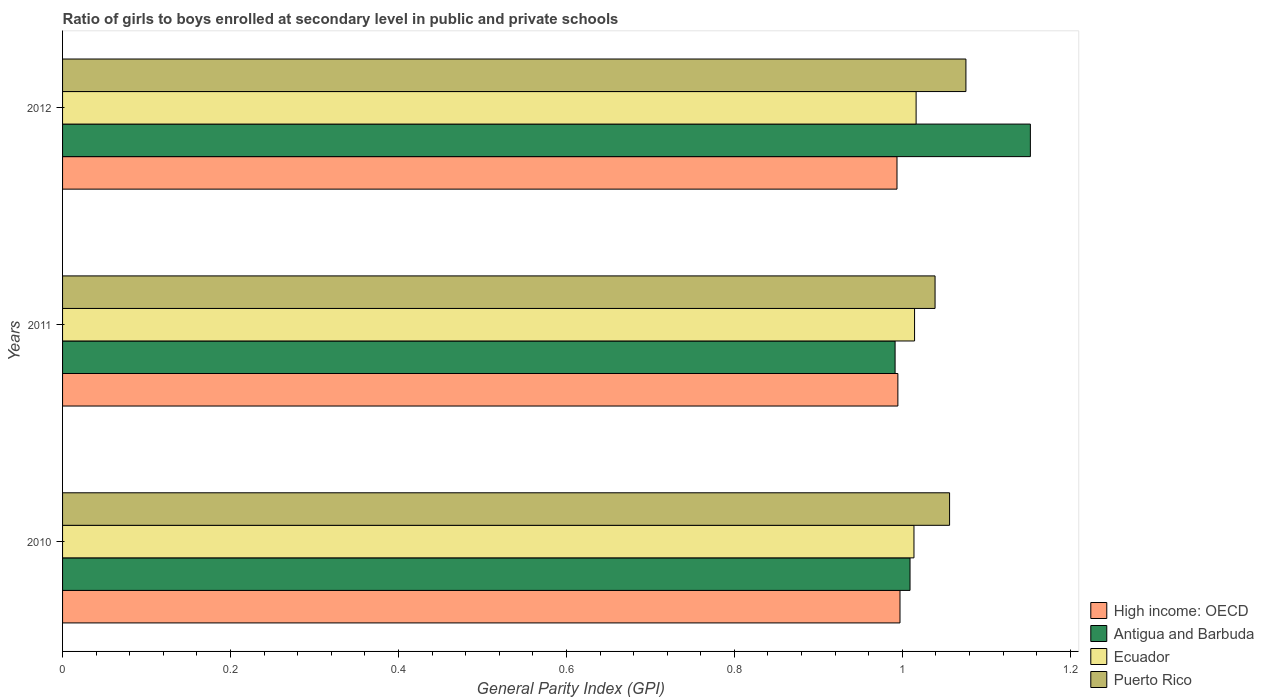How many bars are there on the 2nd tick from the top?
Offer a terse response. 4. What is the label of the 3rd group of bars from the top?
Your answer should be very brief. 2010. What is the general parity index in Antigua and Barbuda in 2012?
Provide a short and direct response. 1.15. Across all years, what is the maximum general parity index in Ecuador?
Keep it short and to the point. 1.02. Across all years, what is the minimum general parity index in Puerto Rico?
Keep it short and to the point. 1.04. In which year was the general parity index in Ecuador minimum?
Provide a short and direct response. 2010. What is the total general parity index in High income: OECD in the graph?
Offer a very short reply. 2.99. What is the difference between the general parity index in Ecuador in 2010 and that in 2011?
Your response must be concise. -0. What is the difference between the general parity index in Puerto Rico in 2011 and the general parity index in Ecuador in 2012?
Your response must be concise. 0.02. What is the average general parity index in Ecuador per year?
Keep it short and to the point. 1.01. In the year 2011, what is the difference between the general parity index in Puerto Rico and general parity index in Antigua and Barbuda?
Keep it short and to the point. 0.05. In how many years, is the general parity index in High income: OECD greater than 0.24000000000000002 ?
Give a very brief answer. 3. What is the ratio of the general parity index in Puerto Rico in 2010 to that in 2011?
Give a very brief answer. 1.02. Is the difference between the general parity index in Puerto Rico in 2011 and 2012 greater than the difference between the general parity index in Antigua and Barbuda in 2011 and 2012?
Give a very brief answer. Yes. What is the difference between the highest and the second highest general parity index in High income: OECD?
Provide a succinct answer. 0. What is the difference between the highest and the lowest general parity index in Puerto Rico?
Your answer should be very brief. 0.04. What does the 3rd bar from the top in 2012 represents?
Provide a short and direct response. Antigua and Barbuda. What does the 2nd bar from the bottom in 2012 represents?
Your answer should be compact. Antigua and Barbuda. How many bars are there?
Provide a short and direct response. 12. Are all the bars in the graph horizontal?
Make the answer very short. Yes. How many years are there in the graph?
Provide a short and direct response. 3. What is the difference between two consecutive major ticks on the X-axis?
Provide a short and direct response. 0.2. Are the values on the major ticks of X-axis written in scientific E-notation?
Ensure brevity in your answer.  No. Does the graph contain any zero values?
Make the answer very short. No. Does the graph contain grids?
Keep it short and to the point. No. How many legend labels are there?
Offer a very short reply. 4. What is the title of the graph?
Provide a short and direct response. Ratio of girls to boys enrolled at secondary level in public and private schools. Does "Syrian Arab Republic" appear as one of the legend labels in the graph?
Your answer should be very brief. No. What is the label or title of the X-axis?
Provide a succinct answer. General Parity Index (GPI). What is the label or title of the Y-axis?
Your response must be concise. Years. What is the General Parity Index (GPI) of High income: OECD in 2010?
Ensure brevity in your answer.  1. What is the General Parity Index (GPI) of Antigua and Barbuda in 2010?
Make the answer very short. 1.01. What is the General Parity Index (GPI) in Ecuador in 2010?
Your response must be concise. 1.01. What is the General Parity Index (GPI) of Puerto Rico in 2010?
Your response must be concise. 1.06. What is the General Parity Index (GPI) in High income: OECD in 2011?
Your answer should be compact. 0.99. What is the General Parity Index (GPI) in Antigua and Barbuda in 2011?
Keep it short and to the point. 0.99. What is the General Parity Index (GPI) of Ecuador in 2011?
Provide a succinct answer. 1.01. What is the General Parity Index (GPI) of Puerto Rico in 2011?
Give a very brief answer. 1.04. What is the General Parity Index (GPI) of High income: OECD in 2012?
Your response must be concise. 0.99. What is the General Parity Index (GPI) of Antigua and Barbuda in 2012?
Provide a succinct answer. 1.15. What is the General Parity Index (GPI) in Ecuador in 2012?
Offer a very short reply. 1.02. What is the General Parity Index (GPI) of Puerto Rico in 2012?
Your response must be concise. 1.08. Across all years, what is the maximum General Parity Index (GPI) in High income: OECD?
Make the answer very short. 1. Across all years, what is the maximum General Parity Index (GPI) of Antigua and Barbuda?
Provide a short and direct response. 1.15. Across all years, what is the maximum General Parity Index (GPI) in Ecuador?
Keep it short and to the point. 1.02. Across all years, what is the maximum General Parity Index (GPI) of Puerto Rico?
Your answer should be very brief. 1.08. Across all years, what is the minimum General Parity Index (GPI) of High income: OECD?
Give a very brief answer. 0.99. Across all years, what is the minimum General Parity Index (GPI) of Antigua and Barbuda?
Offer a very short reply. 0.99. Across all years, what is the minimum General Parity Index (GPI) of Ecuador?
Provide a succinct answer. 1.01. Across all years, what is the minimum General Parity Index (GPI) of Puerto Rico?
Make the answer very short. 1.04. What is the total General Parity Index (GPI) in High income: OECD in the graph?
Offer a terse response. 2.99. What is the total General Parity Index (GPI) of Antigua and Barbuda in the graph?
Keep it short and to the point. 3.15. What is the total General Parity Index (GPI) of Ecuador in the graph?
Your answer should be compact. 3.04. What is the total General Parity Index (GPI) of Puerto Rico in the graph?
Ensure brevity in your answer.  3.17. What is the difference between the General Parity Index (GPI) in High income: OECD in 2010 and that in 2011?
Offer a very short reply. 0. What is the difference between the General Parity Index (GPI) in Antigua and Barbuda in 2010 and that in 2011?
Keep it short and to the point. 0.02. What is the difference between the General Parity Index (GPI) of Ecuador in 2010 and that in 2011?
Ensure brevity in your answer.  -0. What is the difference between the General Parity Index (GPI) in Puerto Rico in 2010 and that in 2011?
Give a very brief answer. 0.02. What is the difference between the General Parity Index (GPI) of High income: OECD in 2010 and that in 2012?
Keep it short and to the point. 0. What is the difference between the General Parity Index (GPI) in Antigua and Barbuda in 2010 and that in 2012?
Keep it short and to the point. -0.14. What is the difference between the General Parity Index (GPI) of Ecuador in 2010 and that in 2012?
Provide a succinct answer. -0. What is the difference between the General Parity Index (GPI) of Puerto Rico in 2010 and that in 2012?
Provide a short and direct response. -0.02. What is the difference between the General Parity Index (GPI) of Antigua and Barbuda in 2011 and that in 2012?
Provide a succinct answer. -0.16. What is the difference between the General Parity Index (GPI) in Ecuador in 2011 and that in 2012?
Offer a very short reply. -0. What is the difference between the General Parity Index (GPI) of Puerto Rico in 2011 and that in 2012?
Provide a short and direct response. -0.04. What is the difference between the General Parity Index (GPI) of High income: OECD in 2010 and the General Parity Index (GPI) of Antigua and Barbuda in 2011?
Give a very brief answer. 0.01. What is the difference between the General Parity Index (GPI) in High income: OECD in 2010 and the General Parity Index (GPI) in Ecuador in 2011?
Provide a short and direct response. -0.02. What is the difference between the General Parity Index (GPI) of High income: OECD in 2010 and the General Parity Index (GPI) of Puerto Rico in 2011?
Your answer should be very brief. -0.04. What is the difference between the General Parity Index (GPI) of Antigua and Barbuda in 2010 and the General Parity Index (GPI) of Ecuador in 2011?
Make the answer very short. -0.01. What is the difference between the General Parity Index (GPI) in Antigua and Barbuda in 2010 and the General Parity Index (GPI) in Puerto Rico in 2011?
Offer a terse response. -0.03. What is the difference between the General Parity Index (GPI) in Ecuador in 2010 and the General Parity Index (GPI) in Puerto Rico in 2011?
Keep it short and to the point. -0.03. What is the difference between the General Parity Index (GPI) in High income: OECD in 2010 and the General Parity Index (GPI) in Antigua and Barbuda in 2012?
Make the answer very short. -0.16. What is the difference between the General Parity Index (GPI) in High income: OECD in 2010 and the General Parity Index (GPI) in Ecuador in 2012?
Offer a very short reply. -0.02. What is the difference between the General Parity Index (GPI) of High income: OECD in 2010 and the General Parity Index (GPI) of Puerto Rico in 2012?
Ensure brevity in your answer.  -0.08. What is the difference between the General Parity Index (GPI) in Antigua and Barbuda in 2010 and the General Parity Index (GPI) in Ecuador in 2012?
Your answer should be very brief. -0.01. What is the difference between the General Parity Index (GPI) of Antigua and Barbuda in 2010 and the General Parity Index (GPI) of Puerto Rico in 2012?
Your answer should be compact. -0.07. What is the difference between the General Parity Index (GPI) of Ecuador in 2010 and the General Parity Index (GPI) of Puerto Rico in 2012?
Ensure brevity in your answer.  -0.06. What is the difference between the General Parity Index (GPI) of High income: OECD in 2011 and the General Parity Index (GPI) of Antigua and Barbuda in 2012?
Your response must be concise. -0.16. What is the difference between the General Parity Index (GPI) in High income: OECD in 2011 and the General Parity Index (GPI) in Ecuador in 2012?
Provide a succinct answer. -0.02. What is the difference between the General Parity Index (GPI) in High income: OECD in 2011 and the General Parity Index (GPI) in Puerto Rico in 2012?
Give a very brief answer. -0.08. What is the difference between the General Parity Index (GPI) of Antigua and Barbuda in 2011 and the General Parity Index (GPI) of Ecuador in 2012?
Your response must be concise. -0.03. What is the difference between the General Parity Index (GPI) in Antigua and Barbuda in 2011 and the General Parity Index (GPI) in Puerto Rico in 2012?
Your answer should be very brief. -0.08. What is the difference between the General Parity Index (GPI) of Ecuador in 2011 and the General Parity Index (GPI) of Puerto Rico in 2012?
Provide a succinct answer. -0.06. What is the average General Parity Index (GPI) of High income: OECD per year?
Make the answer very short. 1. What is the average General Parity Index (GPI) in Antigua and Barbuda per year?
Your response must be concise. 1.05. What is the average General Parity Index (GPI) of Ecuador per year?
Keep it short and to the point. 1.01. What is the average General Parity Index (GPI) in Puerto Rico per year?
Make the answer very short. 1.06. In the year 2010, what is the difference between the General Parity Index (GPI) in High income: OECD and General Parity Index (GPI) in Antigua and Barbuda?
Provide a succinct answer. -0.01. In the year 2010, what is the difference between the General Parity Index (GPI) of High income: OECD and General Parity Index (GPI) of Ecuador?
Your answer should be very brief. -0.02. In the year 2010, what is the difference between the General Parity Index (GPI) of High income: OECD and General Parity Index (GPI) of Puerto Rico?
Ensure brevity in your answer.  -0.06. In the year 2010, what is the difference between the General Parity Index (GPI) of Antigua and Barbuda and General Parity Index (GPI) of Ecuador?
Provide a succinct answer. -0. In the year 2010, what is the difference between the General Parity Index (GPI) of Antigua and Barbuda and General Parity Index (GPI) of Puerto Rico?
Offer a very short reply. -0.05. In the year 2010, what is the difference between the General Parity Index (GPI) of Ecuador and General Parity Index (GPI) of Puerto Rico?
Offer a very short reply. -0.04. In the year 2011, what is the difference between the General Parity Index (GPI) in High income: OECD and General Parity Index (GPI) in Antigua and Barbuda?
Give a very brief answer. 0. In the year 2011, what is the difference between the General Parity Index (GPI) in High income: OECD and General Parity Index (GPI) in Ecuador?
Give a very brief answer. -0.02. In the year 2011, what is the difference between the General Parity Index (GPI) in High income: OECD and General Parity Index (GPI) in Puerto Rico?
Provide a succinct answer. -0.04. In the year 2011, what is the difference between the General Parity Index (GPI) in Antigua and Barbuda and General Parity Index (GPI) in Ecuador?
Keep it short and to the point. -0.02. In the year 2011, what is the difference between the General Parity Index (GPI) in Antigua and Barbuda and General Parity Index (GPI) in Puerto Rico?
Make the answer very short. -0.05. In the year 2011, what is the difference between the General Parity Index (GPI) of Ecuador and General Parity Index (GPI) of Puerto Rico?
Offer a terse response. -0.02. In the year 2012, what is the difference between the General Parity Index (GPI) in High income: OECD and General Parity Index (GPI) in Antigua and Barbuda?
Keep it short and to the point. -0.16. In the year 2012, what is the difference between the General Parity Index (GPI) in High income: OECD and General Parity Index (GPI) in Ecuador?
Offer a very short reply. -0.02. In the year 2012, what is the difference between the General Parity Index (GPI) in High income: OECD and General Parity Index (GPI) in Puerto Rico?
Your answer should be compact. -0.08. In the year 2012, what is the difference between the General Parity Index (GPI) of Antigua and Barbuda and General Parity Index (GPI) of Ecuador?
Offer a very short reply. 0.14. In the year 2012, what is the difference between the General Parity Index (GPI) of Antigua and Barbuda and General Parity Index (GPI) of Puerto Rico?
Ensure brevity in your answer.  0.08. In the year 2012, what is the difference between the General Parity Index (GPI) of Ecuador and General Parity Index (GPI) of Puerto Rico?
Your response must be concise. -0.06. What is the ratio of the General Parity Index (GPI) in High income: OECD in 2010 to that in 2011?
Offer a terse response. 1. What is the ratio of the General Parity Index (GPI) in Antigua and Barbuda in 2010 to that in 2011?
Your answer should be very brief. 1.02. What is the ratio of the General Parity Index (GPI) of Puerto Rico in 2010 to that in 2011?
Your answer should be very brief. 1.02. What is the ratio of the General Parity Index (GPI) in High income: OECD in 2010 to that in 2012?
Your answer should be compact. 1. What is the ratio of the General Parity Index (GPI) of Antigua and Barbuda in 2010 to that in 2012?
Make the answer very short. 0.88. What is the ratio of the General Parity Index (GPI) in Ecuador in 2010 to that in 2012?
Ensure brevity in your answer.  1. What is the ratio of the General Parity Index (GPI) of Puerto Rico in 2010 to that in 2012?
Provide a short and direct response. 0.98. What is the ratio of the General Parity Index (GPI) of Antigua and Barbuda in 2011 to that in 2012?
Provide a short and direct response. 0.86. What is the ratio of the General Parity Index (GPI) in Puerto Rico in 2011 to that in 2012?
Keep it short and to the point. 0.97. What is the difference between the highest and the second highest General Parity Index (GPI) in High income: OECD?
Offer a terse response. 0. What is the difference between the highest and the second highest General Parity Index (GPI) in Antigua and Barbuda?
Provide a succinct answer. 0.14. What is the difference between the highest and the second highest General Parity Index (GPI) in Ecuador?
Provide a short and direct response. 0. What is the difference between the highest and the second highest General Parity Index (GPI) in Puerto Rico?
Provide a short and direct response. 0.02. What is the difference between the highest and the lowest General Parity Index (GPI) of High income: OECD?
Provide a short and direct response. 0. What is the difference between the highest and the lowest General Parity Index (GPI) of Antigua and Barbuda?
Your answer should be compact. 0.16. What is the difference between the highest and the lowest General Parity Index (GPI) of Ecuador?
Offer a very short reply. 0. What is the difference between the highest and the lowest General Parity Index (GPI) in Puerto Rico?
Provide a succinct answer. 0.04. 